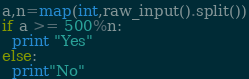<code> <loc_0><loc_0><loc_500><loc_500><_Python_>a,n=map(int,raw_input().split())
if a >= 500%n: 
  print "Yes"
else: 
  print"No"</code> 